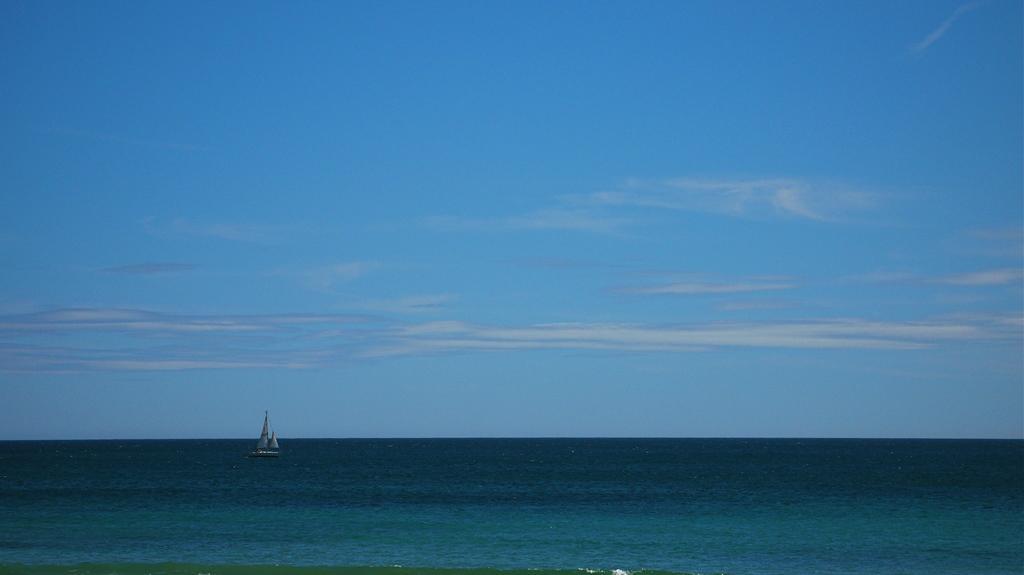In one or two sentences, can you explain what this image depicts? In this image we can see a boat sailing on water. At the top we can see the sky. 